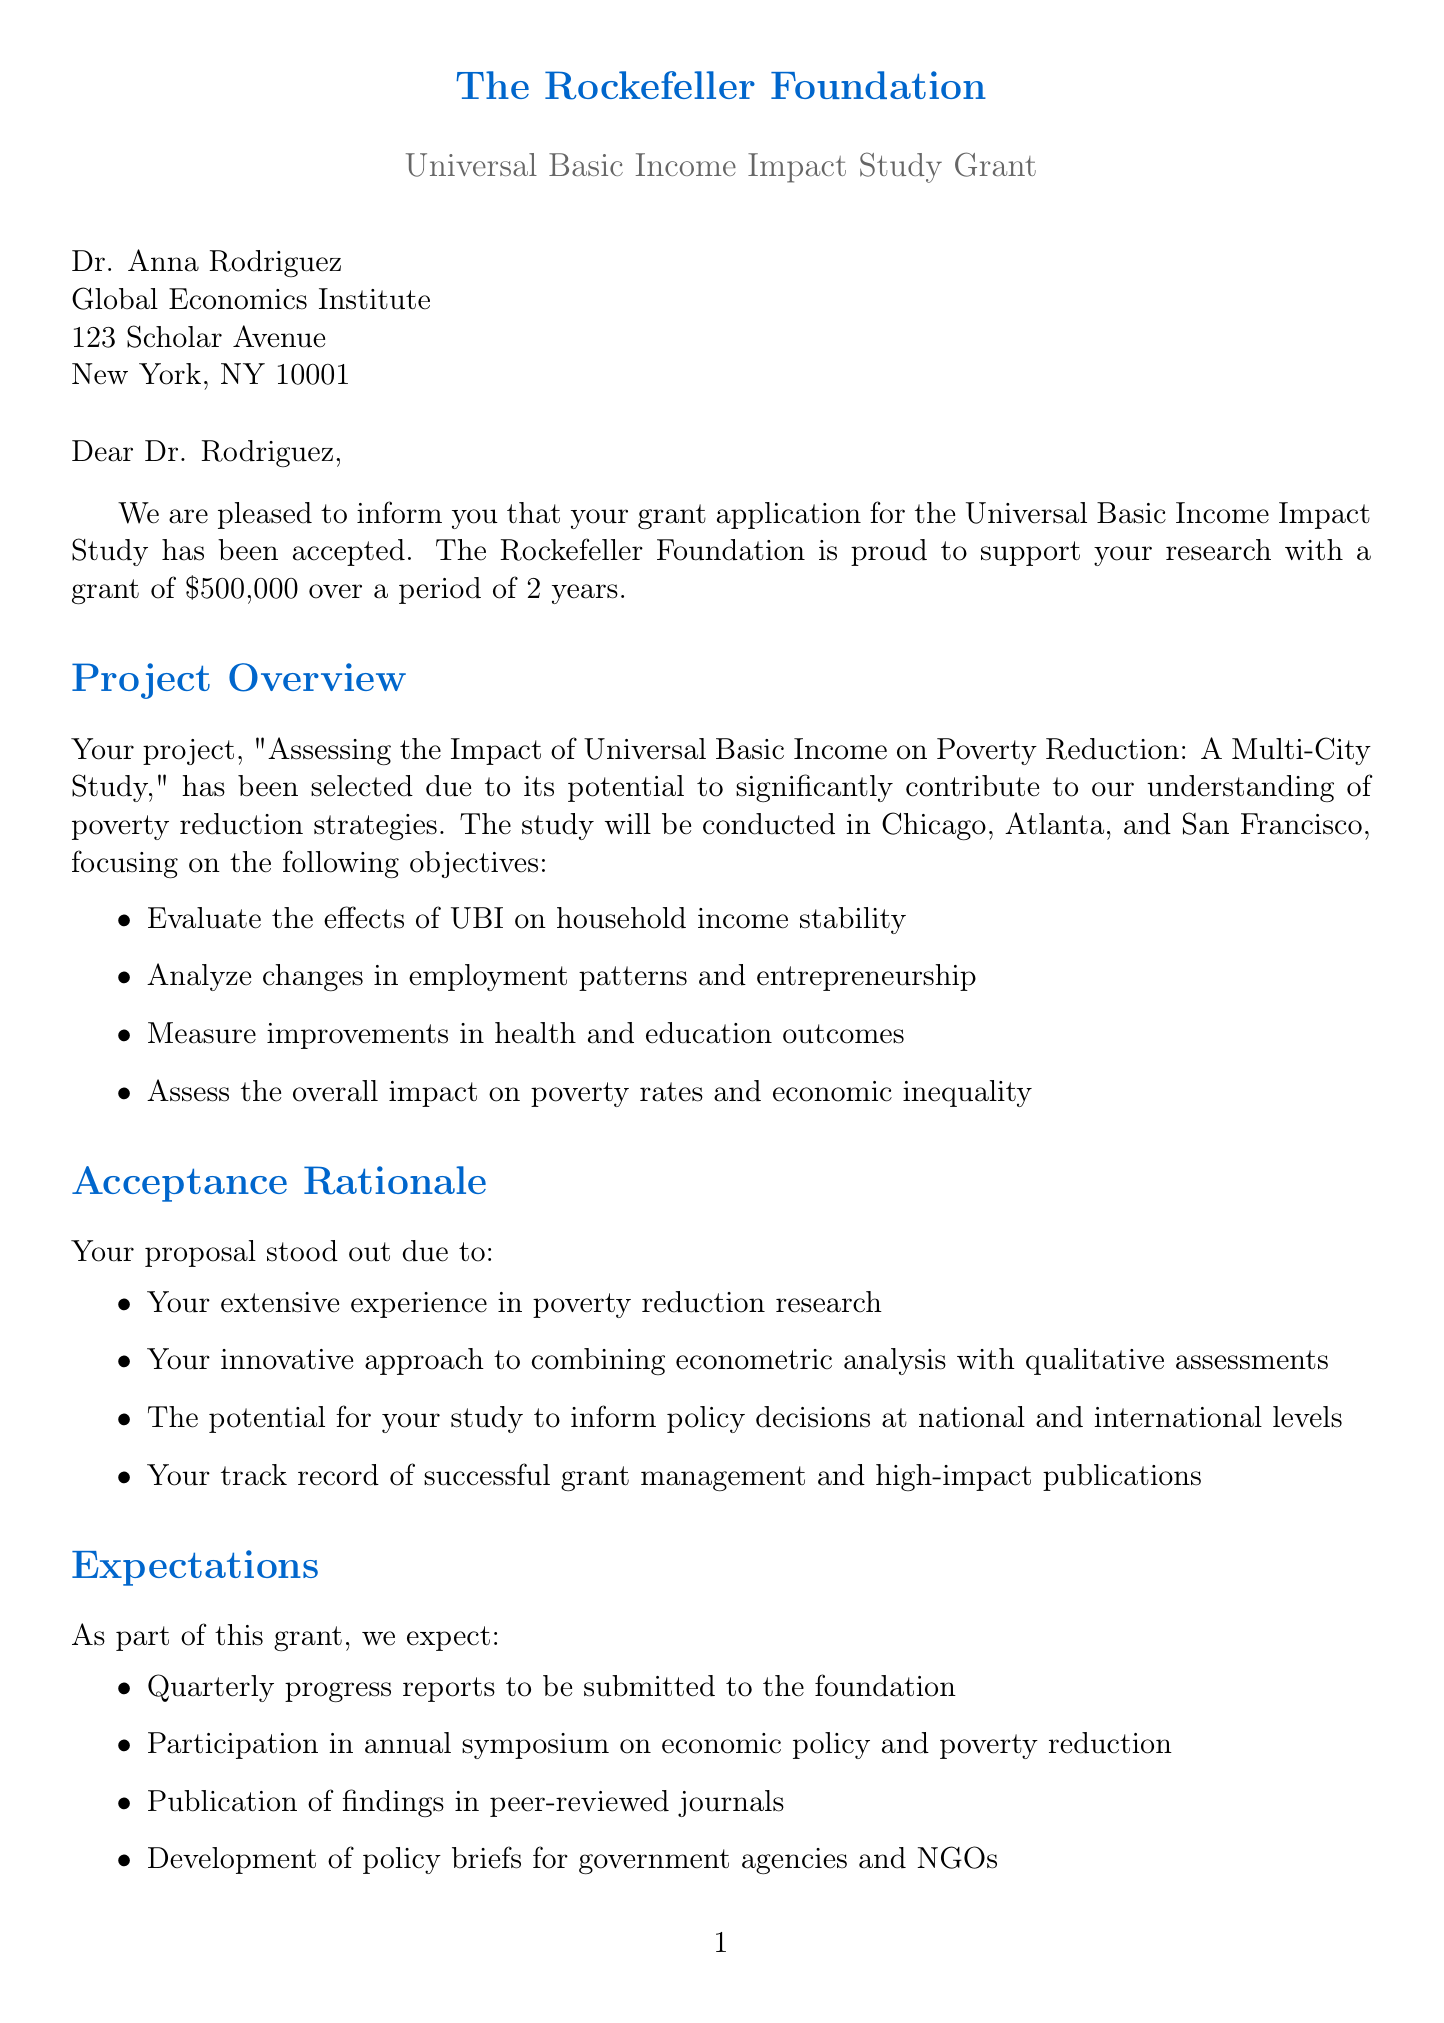what is the name of the grant? The name of the grant is found specifically in the grant details section of the document.
Answer: Universal Basic Income Impact Study Grant how much funding will be provided? The funding amount is detailed in the grant details section of the document.
Answer: $500,000 what are the study locations? The study locations are listed in the project overview section of the letter.
Answer: Chicago, Atlanta, San Francisco what is the duration of the grant? The duration of the grant is stated in the grant details section of the document.
Answer: 2 years what is one objective of the study? Objectives of the study are outlined in the project overview and can be found under the list of objectives.
Answer: Evaluate the effects of UBI on household income stability what is required to proceed with the grant? The next steps include specific actions that must be completed as listed in the next steps section of the document.
Answer: Sign and return the enclosed grant agreement by July 15, 2023 what type of support will the foundation provide? The type of support is detailed in the support provided section of the letter.
Answer: Access to the foundation's network of policymakers and researchers what is the purpose of the quarterly progress reports? The expectations section of the document outlines the purpose of progress reports submitted by the grant recipient.
Answer: To be submitted to the foundation what date is the kickoff meeting scheduled for? The date of the kickoff meeting is mentioned in the next steps section of the document.
Answer: August 1, 2023 